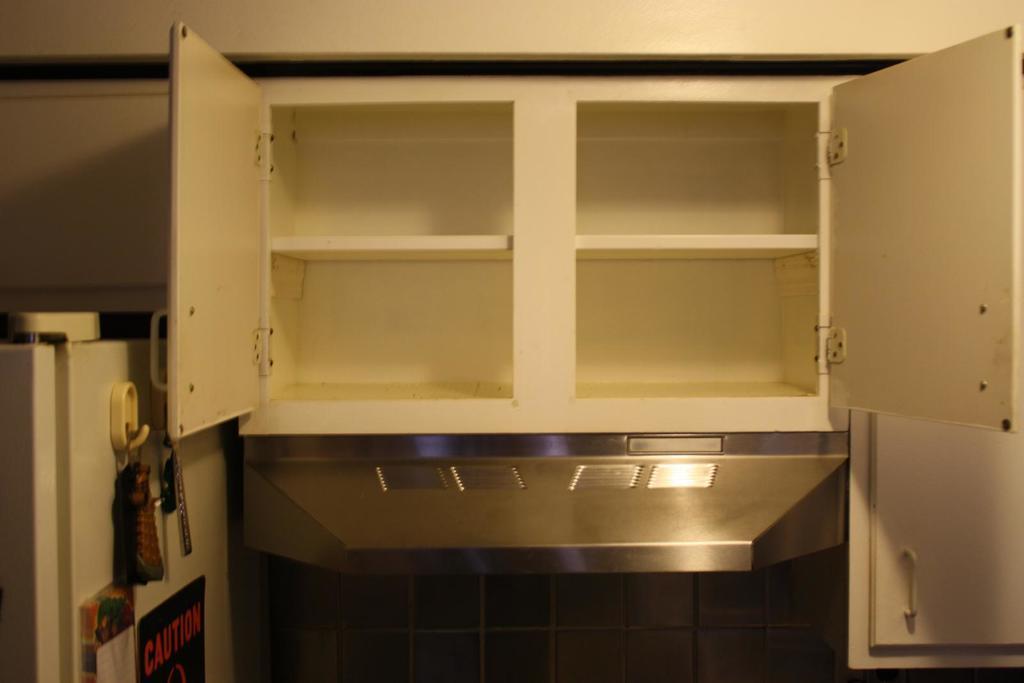Please provide a concise description of this image. In this image we can see a cupboard with doors. On the left side there is a fridge. On that there is a board with something written. Also there are few other things. In the back there is a wall. 